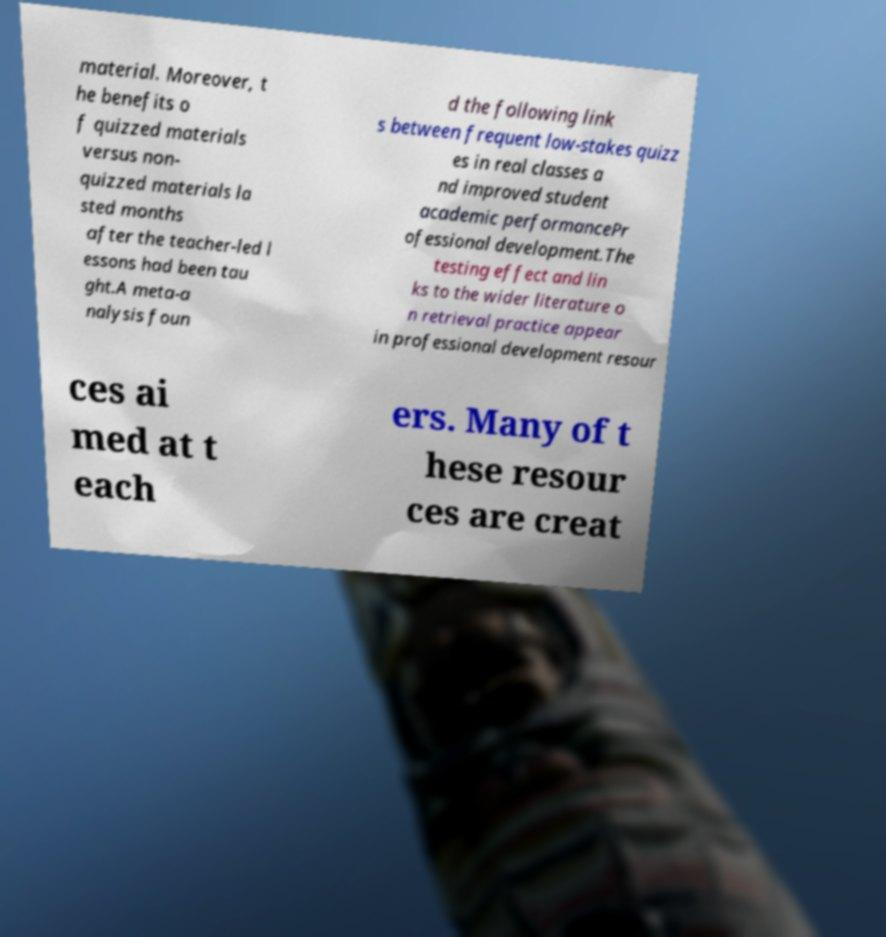Could you extract and type out the text from this image? material. Moreover, t he benefits o f quizzed materials versus non- quizzed materials la sted months after the teacher-led l essons had been tau ght.A meta-a nalysis foun d the following link s between frequent low-stakes quizz es in real classes a nd improved student academic performancePr ofessional development.The testing effect and lin ks to the wider literature o n retrieval practice appear in professional development resour ces ai med at t each ers. Many of t hese resour ces are creat 